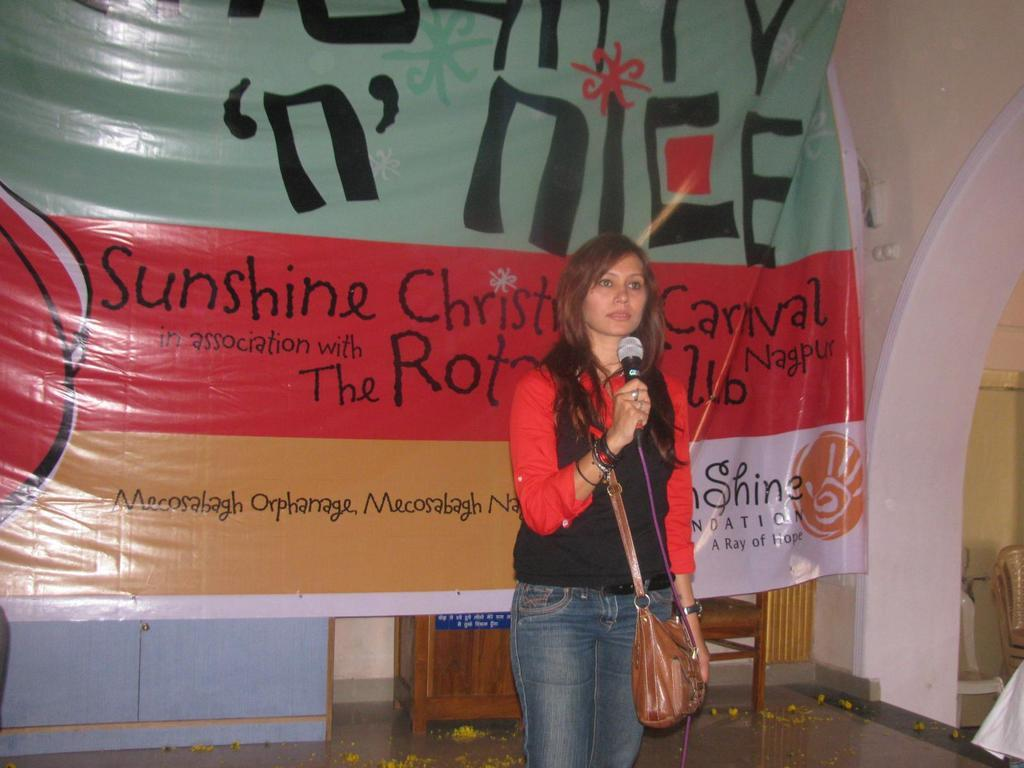Who is the main subject in the image? There is a woman in the image. What is the woman holding in the image? The woman is holding a microphone. What is the woman wearing in the image? The woman is wearing a bag. What type of furniture can be seen in the image? There are chairs in the image. What is visible in the background of the image? There is a banner, a cupboard, and a wall in the background of the image. What type of pet is sitting on the woman's lap in the image? There is no pet visible in the image; the woman is holding a microphone and wearing a bag. 